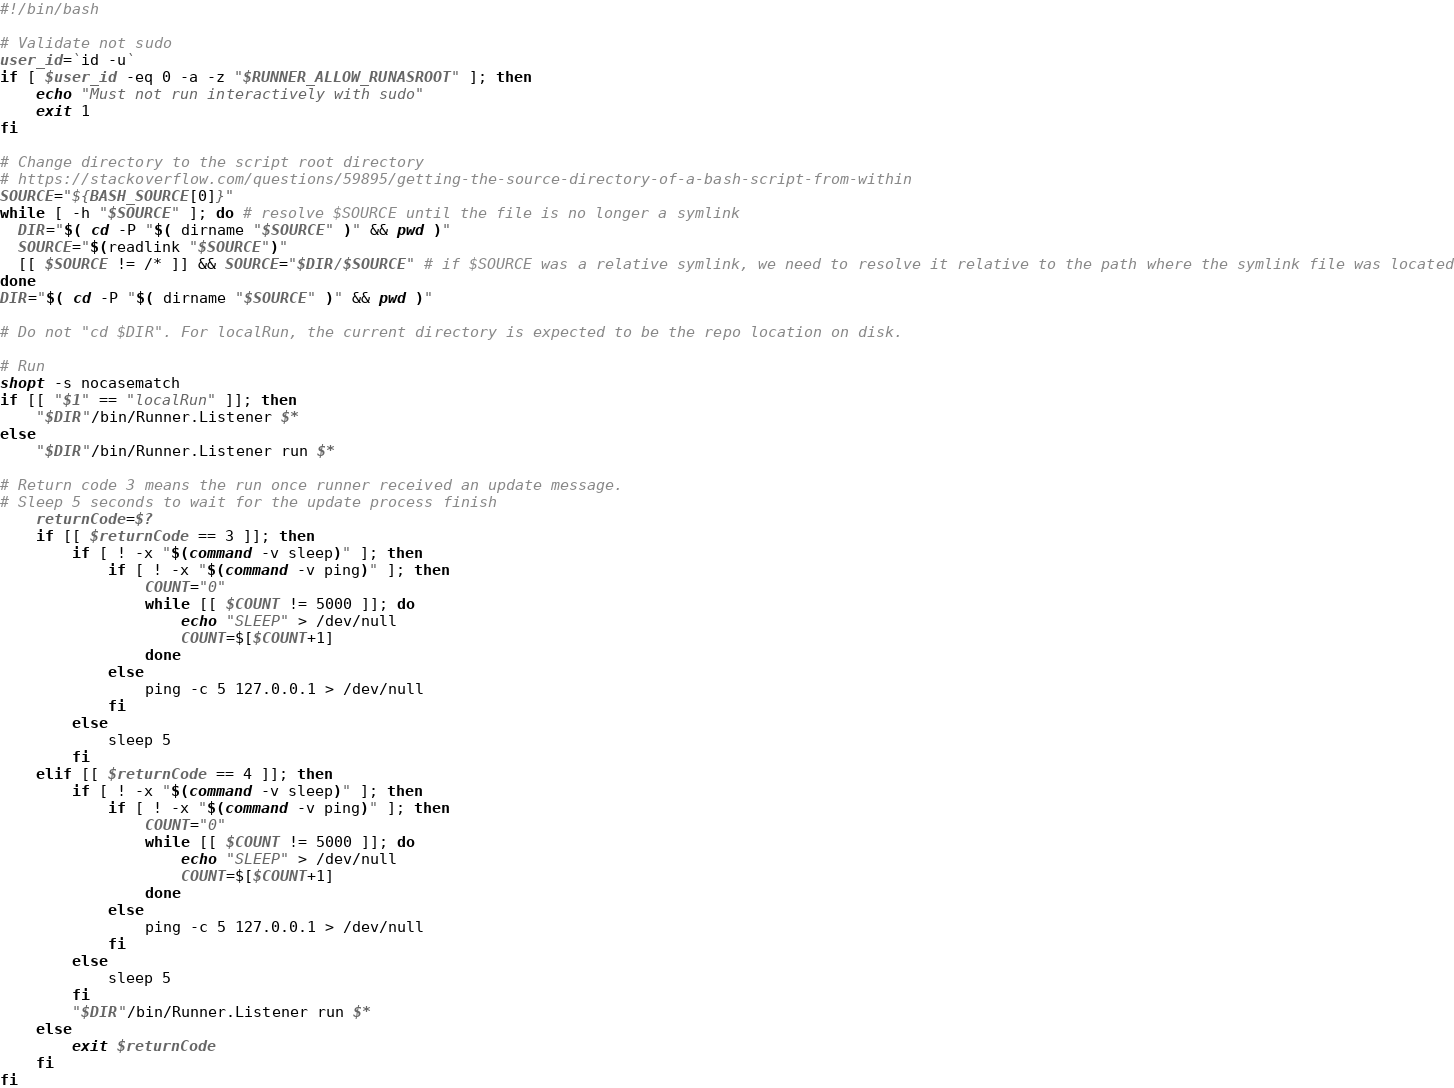<code> <loc_0><loc_0><loc_500><loc_500><_Bash_>#!/bin/bash

# Validate not sudo
user_id=`id -u`
if [ $user_id -eq 0 -a -z "$RUNNER_ALLOW_RUNASROOT" ]; then
    echo "Must not run interactively with sudo"
    exit 1
fi

# Change directory to the script root directory
# https://stackoverflow.com/questions/59895/getting-the-source-directory-of-a-bash-script-from-within
SOURCE="${BASH_SOURCE[0]}"
while [ -h "$SOURCE" ]; do # resolve $SOURCE until the file is no longer a symlink
  DIR="$( cd -P "$( dirname "$SOURCE" )" && pwd )"
  SOURCE="$(readlink "$SOURCE")"
  [[ $SOURCE != /* ]] && SOURCE="$DIR/$SOURCE" # if $SOURCE was a relative symlink, we need to resolve it relative to the path where the symlink file was located
done
DIR="$( cd -P "$( dirname "$SOURCE" )" && pwd )"

# Do not "cd $DIR". For localRun, the current directory is expected to be the repo location on disk.

# Run
shopt -s nocasematch
if [[ "$1" == "localRun" ]]; then
    "$DIR"/bin/Runner.Listener $*
else
    "$DIR"/bin/Runner.Listener run $*

# Return code 3 means the run once runner received an update message.
# Sleep 5 seconds to wait for the update process finish
    returnCode=$?
    if [[ $returnCode == 3 ]]; then
        if [ ! -x "$(command -v sleep)" ]; then
            if [ ! -x "$(command -v ping)" ]; then
                COUNT="0"
                while [[ $COUNT != 5000 ]]; do
                    echo "SLEEP" > /dev/null
                    COUNT=$[$COUNT+1]
                done
            else
                ping -c 5 127.0.0.1 > /dev/null
            fi
        else
            sleep 5
        fi
    elif [[ $returnCode == 4 ]]; then
        if [ ! -x "$(command -v sleep)" ]; then
            if [ ! -x "$(command -v ping)" ]; then
                COUNT="0"
                while [[ $COUNT != 5000 ]]; do
                    echo "SLEEP" > /dev/null
                    COUNT=$[$COUNT+1]
                done
            else
                ping -c 5 127.0.0.1 > /dev/null
            fi
        else
            sleep 5
        fi
        "$DIR"/bin/Runner.Listener run $*
    else
        exit $returnCode
    fi
fi
</code> 